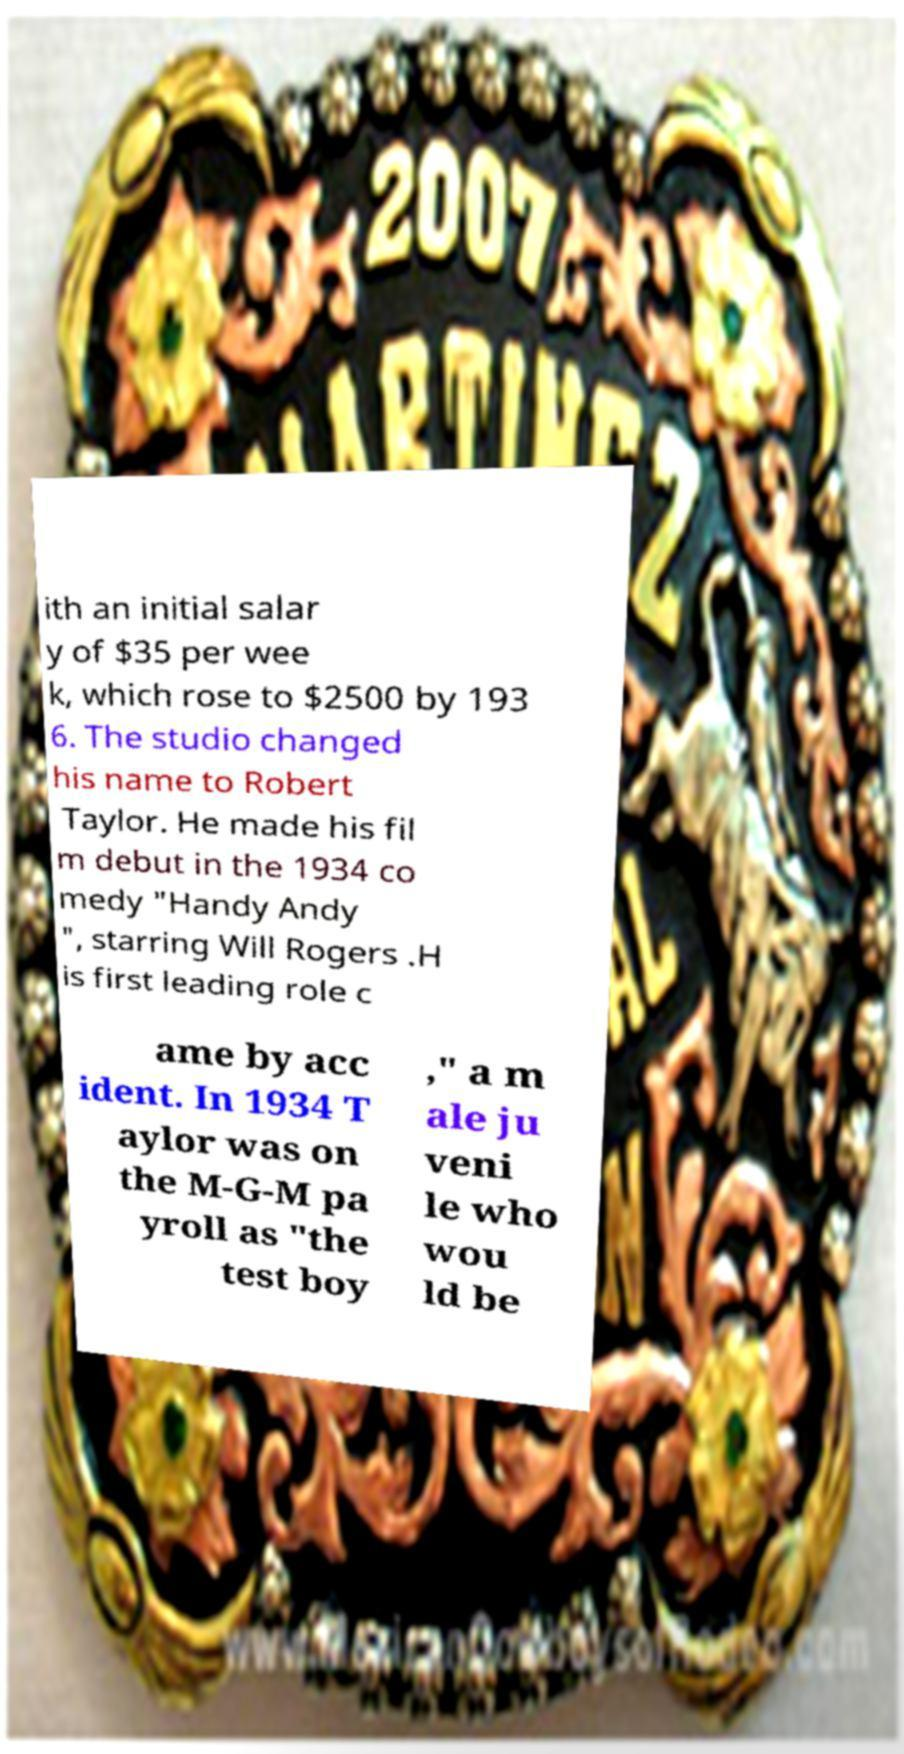Could you assist in decoding the text presented in this image and type it out clearly? ith an initial salar y of $35 per wee k, which rose to $2500 by 193 6. The studio changed his name to Robert Taylor. He made his fil m debut in the 1934 co medy "Handy Andy ", starring Will Rogers .H is first leading role c ame by acc ident. In 1934 T aylor was on the M-G-M pa yroll as "the test boy ," a m ale ju veni le who wou ld be 